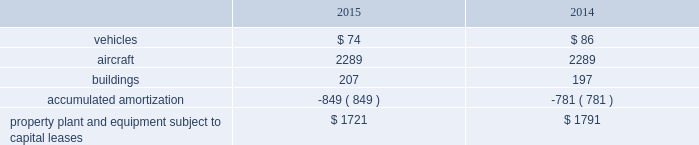United parcel service , inc .
And subsidiaries notes to consolidated financial statements capital lease obligations we have certain property , plant and equipment subject to capital leases .
Some of the obligations associated with these capital leases have been legally defeased .
The recorded value of our property , plant and equipment subject to capital leases is as follows as of december 31 ( in millions ) : .
These capital lease obligations have principal payments due at various dates from 2016 through 3005 .
Facility notes and bonds we have entered into agreements with certain municipalities to finance the construction of , or improvements to , facilities that support our u.s .
Domestic package and supply chain & freight operations in the united states .
These facilities are located around airport properties in louisville , kentucky ; dallas , texas ; and philadelphia , pennsylvania .
Under these arrangements , we enter into a lease or loan agreement that covers the debt service obligations on the bonds issued by the municipalities , as follows : 2022 bonds with a principal balance of $ 149 million issued by the louisville regional airport authority associated with our worldport facility in louisville , kentucky .
The bonds , which are due in january 2029 , bear interest at a variable rate , and the average interest rates for 2015 and 2014 were 0.03% ( 0.03 % ) and 0.05% ( 0.05 % ) , respectively .
2022 bonds with a principal balance of $ 42 million and due in november 2036 issued by the louisville regional airport authority associated with our air freight facility in louisville , kentucky .
The bonds bear interest at a variable rate , and the average interest rates for 2015 and 2014 were 0.02% ( 0.02 % ) and 0.05% ( 0.05 % ) , respectively .
2022 bonds with a principal balance of $ 29 million issued by the dallas / fort worth international airport facility improvement corporation associated with our dallas , texas airport facilities .
The bonds are due in may 2032 and bear interest at a variable rate , however the variable cash flows on the obligation have been swapped to a fixed 5.11% ( 5.11 % ) .
2022 bonds with a principal balance of $ 100 million issued by the delaware county , pennsylvania industrial development authority associated with our philadelphia , pennsylvania airport facilities .
The bonds , which were due in december 2015 , had a variable interest rate , and the average interest rates for 2015 and 2014 were 0.02% ( 0.02 % ) and 0.04% ( 0.04 % ) , respectively .
As of december 2015 , these $ 100 million bonds were repaid in full .
2022 in september 2015 , we entered into an agreement with the delaware county , pennsylvania industrial development authority , associated with our philadelphia , pennsylvania airport facilities , for bonds issued with a principal balance of $ 100 million .
These bonds , which are due september 2045 , bear interest at a variable rate .
The average interest rate for 2015 was 0.00% ( 0.00 % ) .
Pound sterling notes the pound sterling notes consist of two separate tranches , as follows : 2022 notes with a principal amount of a366 million accrue interest at a 5.50% ( 5.50 % ) fixed rate , and are due in february 2031 .
These notes are not callable .
2022 notes with a principal amount of a3455 million accrue interest at a 5.125% ( 5.125 % ) fixed rate , and are due in february 2050 .
These notes are callable at our option at a redemption price equal to the greater of 100% ( 100 % ) of the principal amount and accrued interest , or the sum of the present values of the remaining scheduled payout of principal and interest thereon discounted to the date of redemption at a benchmark u.k .
Government bond yield plus 15 basis points and accrued interest. .
What is the percentage change in vehicles under capital lease between 2014 and 2015? 
Computations: ((74 - 86) / 86)
Answer: -0.13953. 